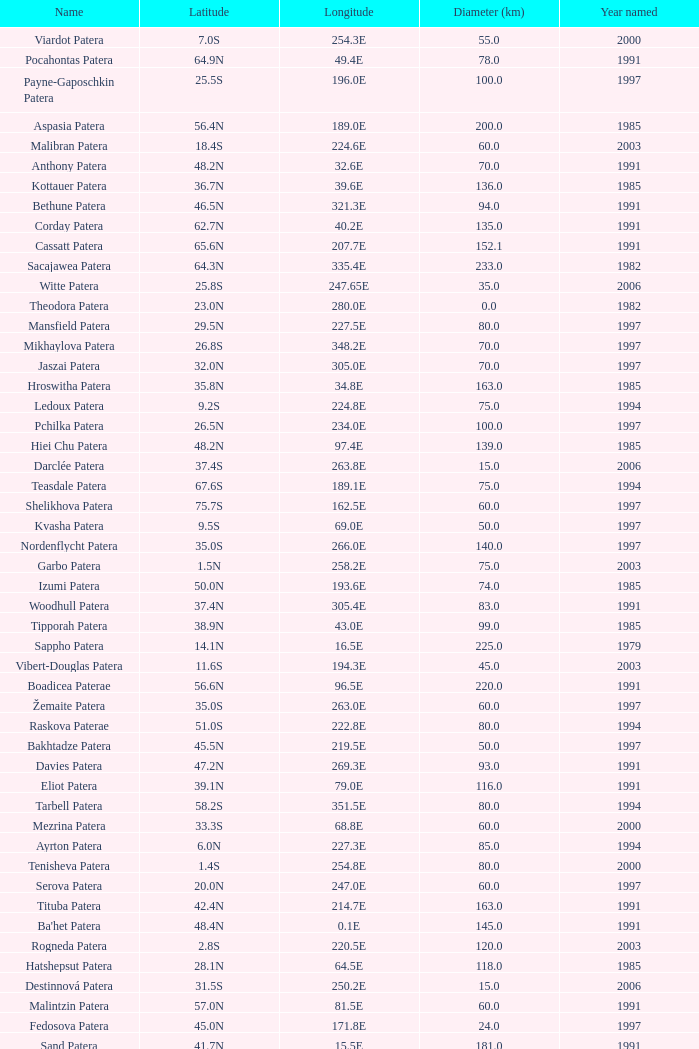Could you help me parse every detail presented in this table? {'header': ['Name', 'Latitude', 'Longitude', 'Diameter (km)', 'Year named'], 'rows': [['Viardot Patera', '7.0S', '254.3E', '55.0', '2000'], ['Pocahontas Patera', '64.9N', '49.4E', '78.0', '1991'], ['Payne-Gaposchkin Patera', '25.5S', '196.0E', '100.0', '1997'], ['Aspasia Patera', '56.4N', '189.0E', '200.0', '1985'], ['Malibran Patera', '18.4S', '224.6E', '60.0', '2003'], ['Anthony Patera', '48.2N', '32.6E', '70.0', '1991'], ['Kottauer Patera', '36.7N', '39.6E', '136.0', '1985'], ['Bethune Patera', '46.5N', '321.3E', '94.0', '1991'], ['Corday Patera', '62.7N', '40.2E', '135.0', '1991'], ['Cassatt Patera', '65.6N', '207.7E', '152.1', '1991'], ['Sacajawea Patera', '64.3N', '335.4E', '233.0', '1982'], ['Witte Patera', '25.8S', '247.65E', '35.0', '2006'], ['Theodora Patera', '23.0N', '280.0E', '0.0', '1982'], ['Mansfield Patera', '29.5N', '227.5E', '80.0', '1997'], ['Mikhaylova Patera', '26.8S', '348.2E', '70.0', '1997'], ['Jaszai Patera', '32.0N', '305.0E', '70.0', '1997'], ['Hroswitha Patera', '35.8N', '34.8E', '163.0', '1985'], ['Ledoux Patera', '9.2S', '224.8E', '75.0', '1994'], ['Pchilka Patera', '26.5N', '234.0E', '100.0', '1997'], ['Hiei Chu Patera', '48.2N', '97.4E', '139.0', '1985'], ['Darclée Patera', '37.4S', '263.8E', '15.0', '2006'], ['Teasdale Patera', '67.6S', '189.1E', '75.0', '1994'], ['Shelikhova Patera', '75.7S', '162.5E', '60.0', '1997'], ['Kvasha Patera', '9.5S', '69.0E', '50.0', '1997'], ['Nordenflycht Patera', '35.0S', '266.0E', '140.0', '1997'], ['Garbo Patera', '1.5N', '258.2E', '75.0', '2003'], ['Izumi Patera', '50.0N', '193.6E', '74.0', '1985'], ['Woodhull Patera', '37.4N', '305.4E', '83.0', '1991'], ['Tipporah Patera', '38.9N', '43.0E', '99.0', '1985'], ['Sappho Patera', '14.1N', '16.5E', '225.0', '1979'], ['Vibert-Douglas Patera', '11.6S', '194.3E', '45.0', '2003'], ['Boadicea Paterae', '56.6N', '96.5E', '220.0', '1991'], ['Žemaite Patera', '35.0S', '263.0E', '60.0', '1997'], ['Raskova Paterae', '51.0S', '222.8E', '80.0', '1994'], ['Bakhtadze Patera', '45.5N', '219.5E', '50.0', '1997'], ['Davies Patera', '47.2N', '269.3E', '93.0', '1991'], ['Eliot Patera', '39.1N', '79.0E', '116.0', '1991'], ['Tarbell Patera', '58.2S', '351.5E', '80.0', '1994'], ['Mezrina Patera', '33.3S', '68.8E', '60.0', '2000'], ['Ayrton Patera', '6.0N', '227.3E', '85.0', '1994'], ['Tenisheva Patera', '1.4S', '254.8E', '80.0', '2000'], ['Serova Patera', '20.0N', '247.0E', '60.0', '1997'], ['Tituba Patera', '42.4N', '214.7E', '163.0', '1991'], ["Ba'het Patera", '48.4N', '0.1E', '145.0', '1991'], ['Rogneda Patera', '2.8S', '220.5E', '120.0', '2003'], ['Hatshepsut Patera', '28.1N', '64.5E', '118.0', '1985'], ['Destinnová Patera', '31.5S', '250.2E', '15.0', '2006'], ['Malintzin Patera', '57.0N', '81.5E', '60.0', '1991'], ['Fedosova Patera', '45.0N', '171.8E', '24.0', '1997'], ['Sand Patera', '41.7N', '15.5E', '181.0', '1991'], ['Tey Patera', '17.8S', '349.1E', '20.0', '1994'], ['Fedchenko Patera', '24.0S', '226.5E', '75.0', '1997'], ['Siddons Patera', '61.6N', '340.6E', '47.0', '1997'], ['Sachs Patera', '49.1N', '334.2E', '65.0', '1991'], ['Graham Patera', '6.0S', '6.0E', '75.0', '1997'], ['Bremer Patera', '66.8N', '63.7E', '91.0', '1991'], ['Dietrich Patera', '5.3S', '235.3E', '100.0', '2003'], ['Garland Patera', '32.7N', '206.8E', '45.0', '2006'], ['Shulzhenko Patera', '6.5N', '264.5E', '60.0', '1997'], ['Lindgren Patera', '28.1N', '241.4E', '110.0', '2006'], ['Anning Paterae', '66.5N', '57.8E', '0.0', '1991'], ['Aitchison Patera', '16.7S', '349.4E', '28.0', '1994'], ['Trotula Patera', '41.3N', '18.9E', '146.0', '1985'], ['Cherskaya Patera', '5.2S', '232.5E', '85.0', '2003'], ['Nikolaeva Patera', '33.9N', '267.5E', '100.0', '2006'], ['Dutrieu Patera', '33.8N', '198.5E', '80.0', '2006'], ['Mehseti Patera', '16.0N', '311.0E', '60.0', '1997'], ['Nzingha Patera', '68.7N', '205.7E', '85.5', '1991'], ['Colette Patera', '66.3N', '322.8E', '149.0', '1982'], ['Yaroslavna Patera', '38.8N', '21.2E', '112.0', '1985'], ['Keller Patera', '45.0N', '274.0E', '69.0', '1991'], ['Kupo Patera', '41.9S', '195.5E', '100.0', '1997'], ['Cavell Patera', '37.9N', '18.7E', '76.0', '1991'], ['Grizodubova Patera', '16.7N', '299.6E', '50.0', '1997'], ['Carriera Patera', '48.6N', '48.8E', '97.0', '1991'], ['Razia Patera', '46.2N', '197.8E', '157.0', '1985'], ['Stopes Patera', '42.6N', '46.5E', '169.0', '1991'], ['Cleopatra Patera', '66.0N', '6.9E', '119.0', '1992'], ['Apgar Patera', '43.1N', '83.8E', '126.0', '1991'], ['Wilde Patera', '21.3S', '266.3E', '75.0', '2000'], ['Vovchok Patera', '38.0S', '310.0E', '80.0', '1997'], ['Bers Patera', '66.7S', '183.0E', '17.0', '2000'], ['Barnes Patera', '15.5S', '229.2E', '15.0', '2003'], ['Panina Patera', '13.0S', '309.8E', '50.0', '1997'], ['Jotuni Patera', '6.5S', '214.0E', '100.0', '1997'], ['Villepreux-Power Patera', '22.0S', '210.0E', '100.0', '1997'], ['Schumann-Heink Patera', '74.3N', '214.5E', '121.7', '1991'], ['Libby Patera', '34.5S', '199.5E', '90.0', '1997']]} What is the average Year Named, when Latitude is 37.9N, and when Diameter (km) is greater than 76? None. 